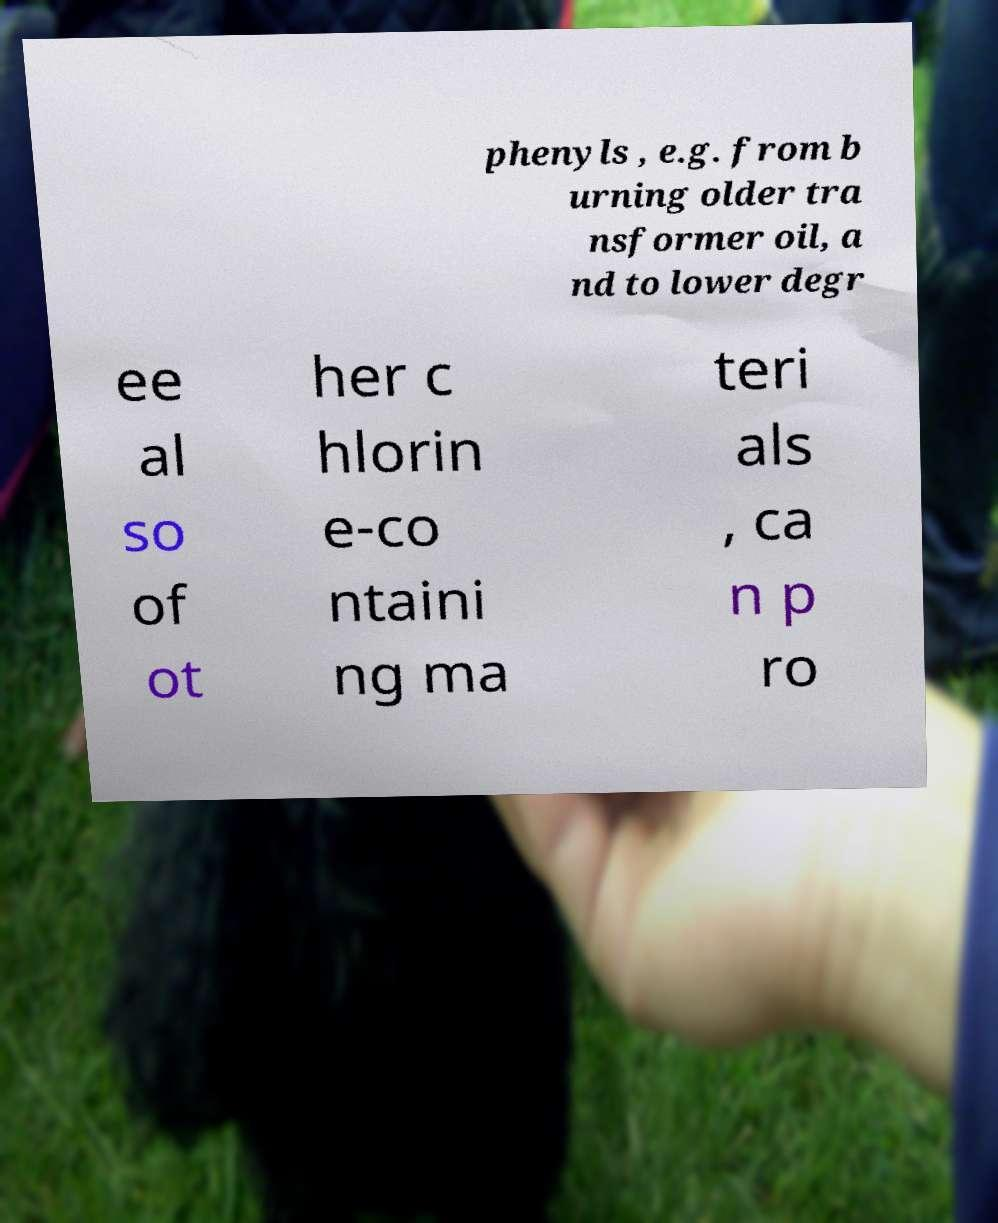I need the written content from this picture converted into text. Can you do that? phenyls , e.g. from b urning older tra nsformer oil, a nd to lower degr ee al so of ot her c hlorin e-co ntaini ng ma teri als , ca n p ro 